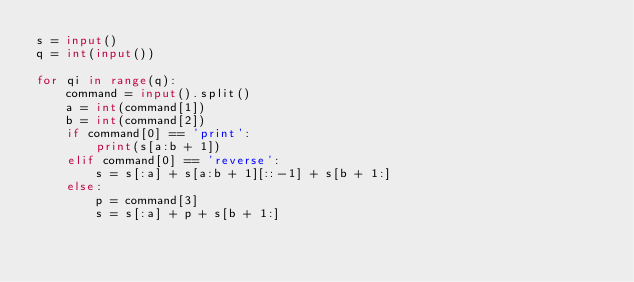<code> <loc_0><loc_0><loc_500><loc_500><_Python_>s = input()
q = int(input())

for qi in range(q):
    command = input().split()
    a = int(command[1])
    b = int(command[2])
    if command[0] == 'print':
        print(s[a:b + 1])
    elif command[0] == 'reverse':
        s = s[:a] + s[a:b + 1][::-1] + s[b + 1:]
    else:
        p = command[3]
        s = s[:a] + p + s[b + 1:]</code> 